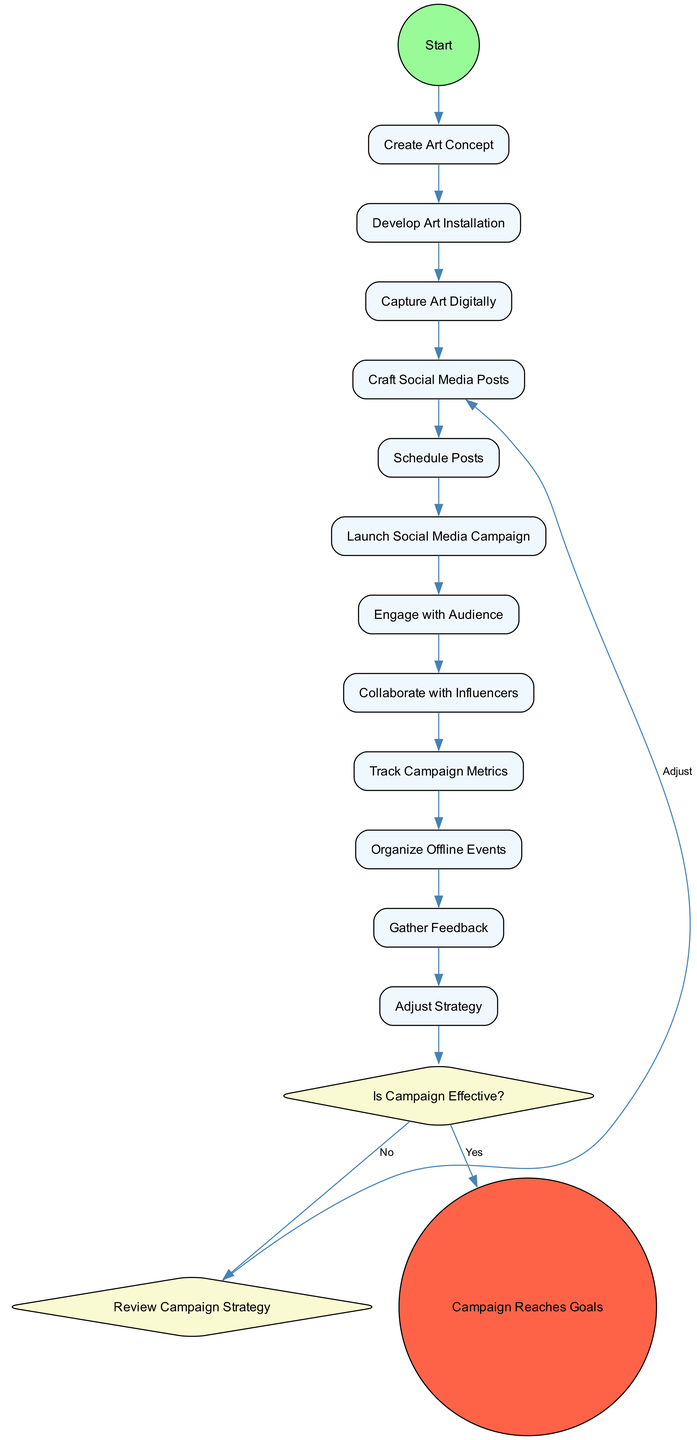What is the first activity in the diagram? The first activity is labeled "Create Art Concept." It is the starting point of the flowchart indicating the beginning of the process.
Answer: Create Art Concept How many activities are depicted in the diagram? By counting the individual activities listed, there are a total of 12 activities shown in the diagram.
Answer: 12 What decision is represented in the diagram? The only decision point shown is "Is Campaign Effective?" which determines the success of the campaign based on metrics and feedback.
Answer: Is Campaign Effective? What happens if the campaign is not effective? If the campaign is not effective, the flow will lead to the "Review Campaign Strategy" merge point, which indicates the need for adjustments to the strategy.
Answer: Review Campaign Strategy What is the last activity before the decision point? The last activity before reaching the decision node is "Capture Art Digitally." It provides context for evaluating the campaign effectiveness.
Answer: Capture Art Digitally How many edges connect the activities in the diagram? By analyzing the connections between nodes, there are a total of 11 edges connecting the activities, leading to the decision point.
Answer: 11 What does the endpoint of the diagram represent? The endpoint of the diagram is "Campaign Reaches Goals," indicating that the campaign has successfully achieved its objectives.
Answer: Campaign Reaches Goals What is the relationship between "Engage with Audience" and "Collaborate with Influencers"? Both activities are sequential in the flow and show the process of interaction and enhancement of the campaign's reach, but they are separate actions taken after launching the campaign.
Answer: Sequential and separate actions Which activity involves digital media? The activity that involves digital media is "Capture Art Digitally", as it focuses on photographing and recording videos of the art installation.
Answer: Capture Art Digitally 